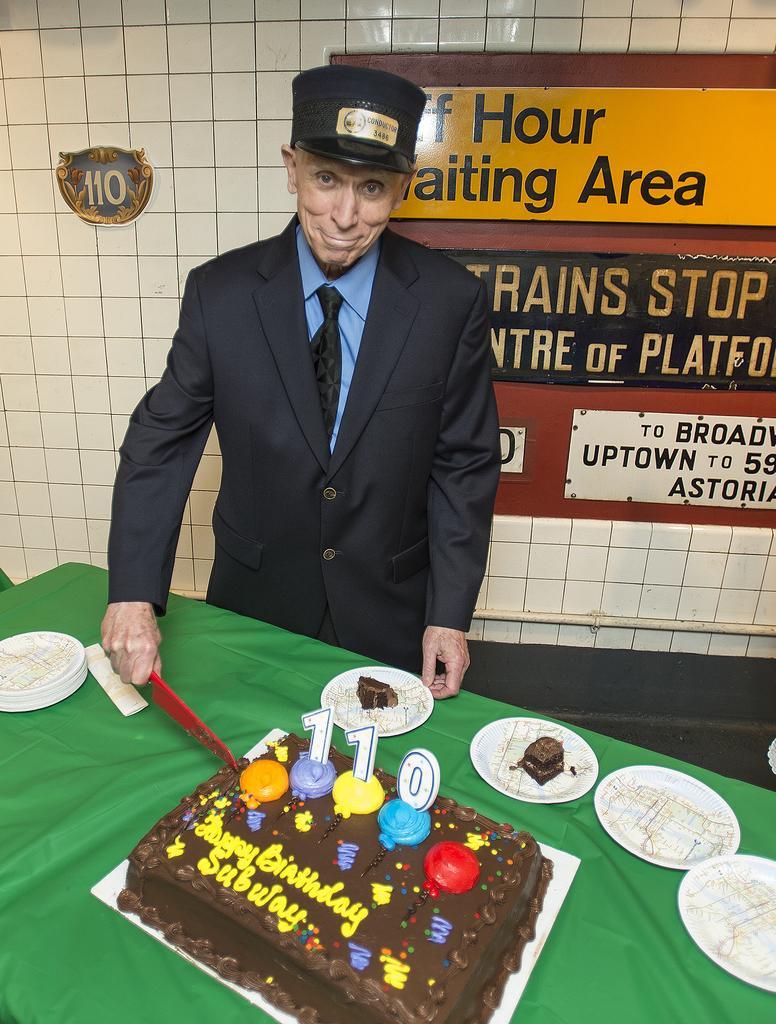Could you give a brief overview of what you see in this image? In this image there is a person wearing a suit , tie and cap is before a table is cutting a cake with knife. There are few plates on table. On background there is a wall having some name board. 